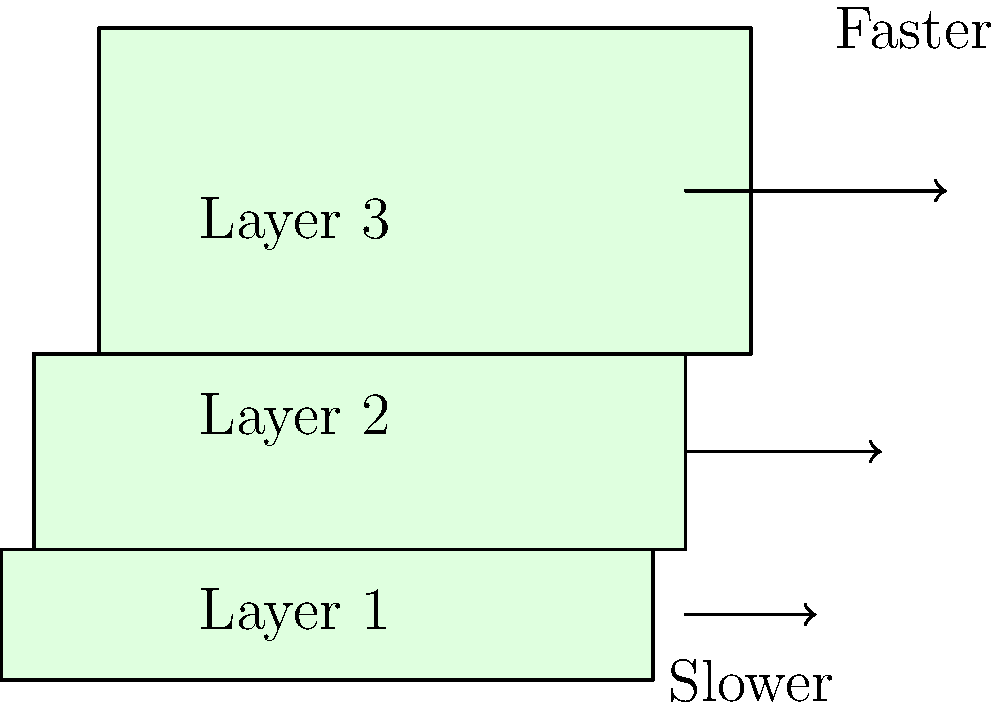In implementing a parallax scrolling effect for your indie game, you have three background layers moving at different speeds. If the closest layer (Layer 3) moves at a speed of 200 pixels per second, and the middle layer (Layer 2) moves at half that speed, how fast should the farthest layer (Layer 1) move to create a realistic depth effect? Express your answer in pixels per second. To create a realistic parallax effect, we need to establish a relationship between the layers' speeds based on their perceived distance from the viewer. Let's break this down step-by-step:

1. We know that Layer 3 (closest) moves at 200 pixels/second.
2. Layer 2 (middle) moves at half the speed of Layer 3, so its speed is 100 pixels/second.
3. To maintain the illusion of depth, Layer 1 (farthest) should move slower than Layer 2.

The general rule for parallax scrolling is that each layer farther from the viewer should move at about half the speed of the layer in front of it. This creates a convincing sense of depth.

Therefore:
* Layer 3 speed = 200 pixels/second
* Layer 2 speed = 100 pixels/second (half of Layer 3)
* Layer 1 speed = 50 pixels/second (half of Layer 2)

We can express this mathematically as:

$$ \text{Speed}_{\text{Layer 1}} = \frac{\text{Speed}_{\text{Layer 3}}}{2^2} = \frac{200}{4} = 50 \text{ pixels/second} $$

This progression of speeds (50, 100, 200) creates a smooth parallax effect that gives the illusion of depth in your 2D game environment.
Answer: 50 pixels/second 